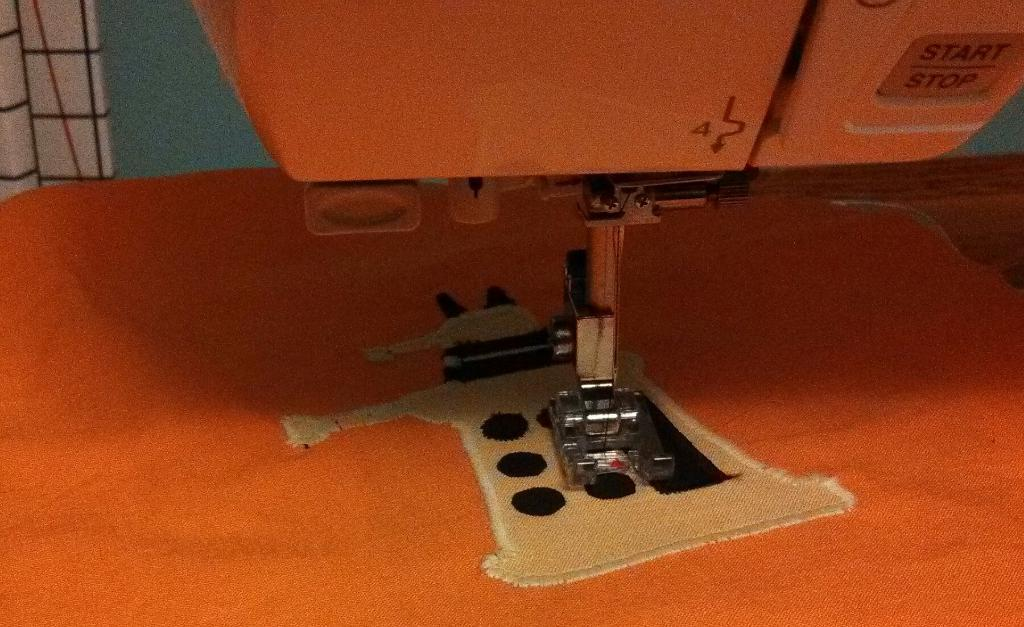What is the main object in the image? There is a sewing machine in the image. What color is the sewing machine? The sewing machine appears to be orange. What is placed under the sewing machine? There is a cloth under the sewing machine. What can be seen behind the sewing machine? There is a wall visible behind the sewing machine. How many oranges are being used to power the sewing machine in the image? There are no oranges present in the image, and the sewing machine is not powered by oranges. What type of crowd can be seen gathering around the sewing machine in the image? There is no crowd present in the image; it only features the sewing machine, cloth, and wall. 